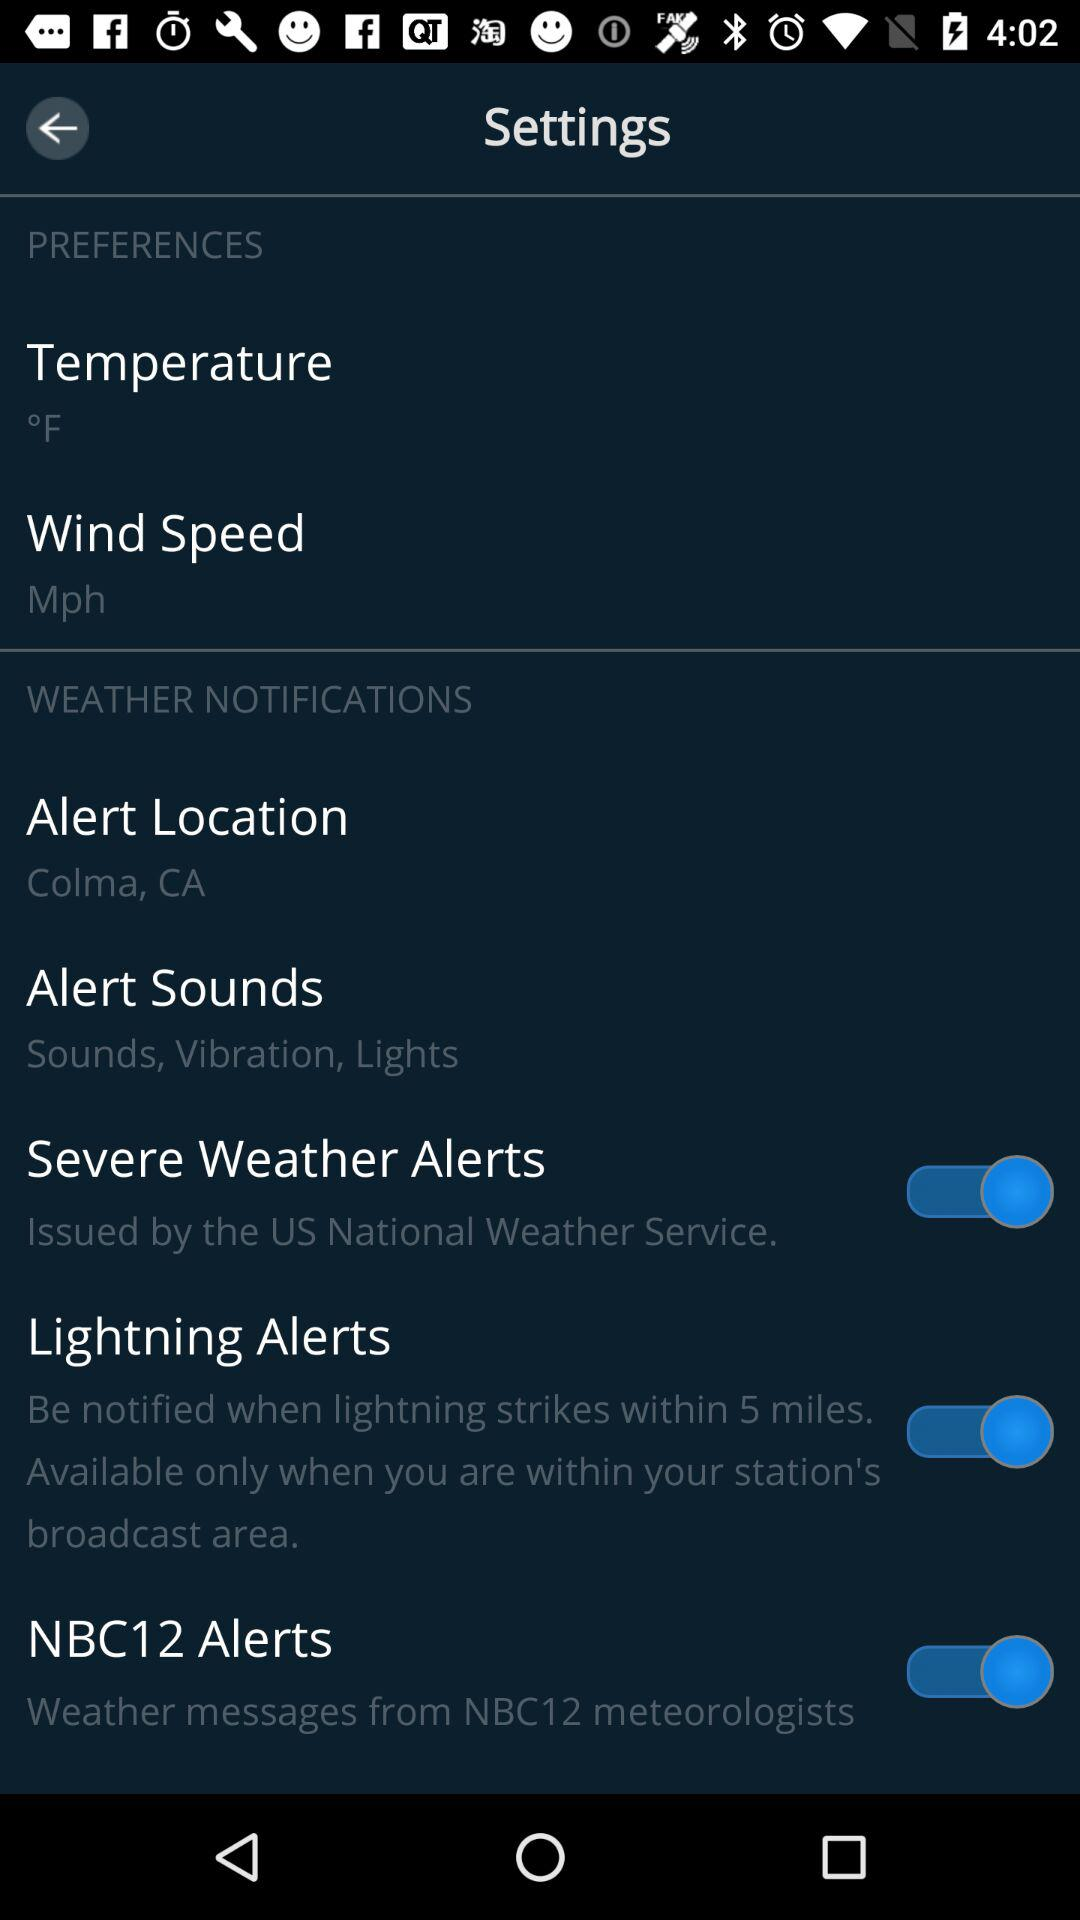What is the alert location? The alert location is Colma, CA. 